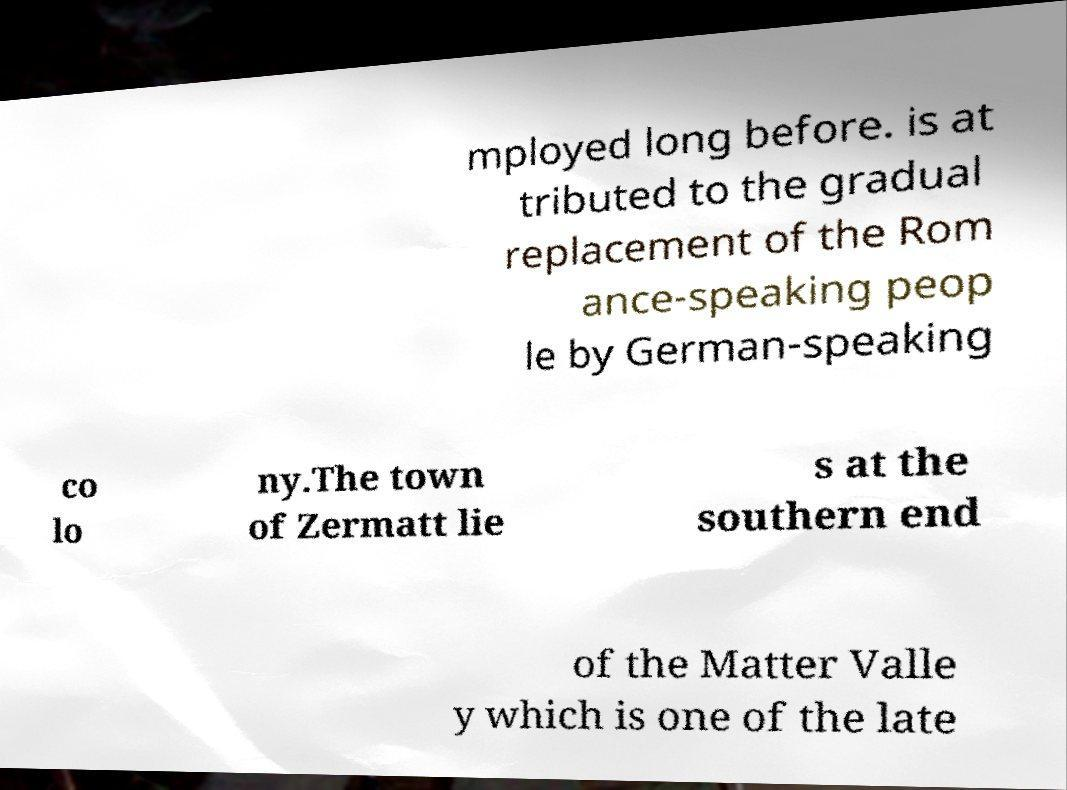Could you assist in decoding the text presented in this image and type it out clearly? mployed long before. is at tributed to the gradual replacement of the Rom ance-speaking peop le by German-speaking co lo ny.The town of Zermatt lie s at the southern end of the Matter Valle y which is one of the late 